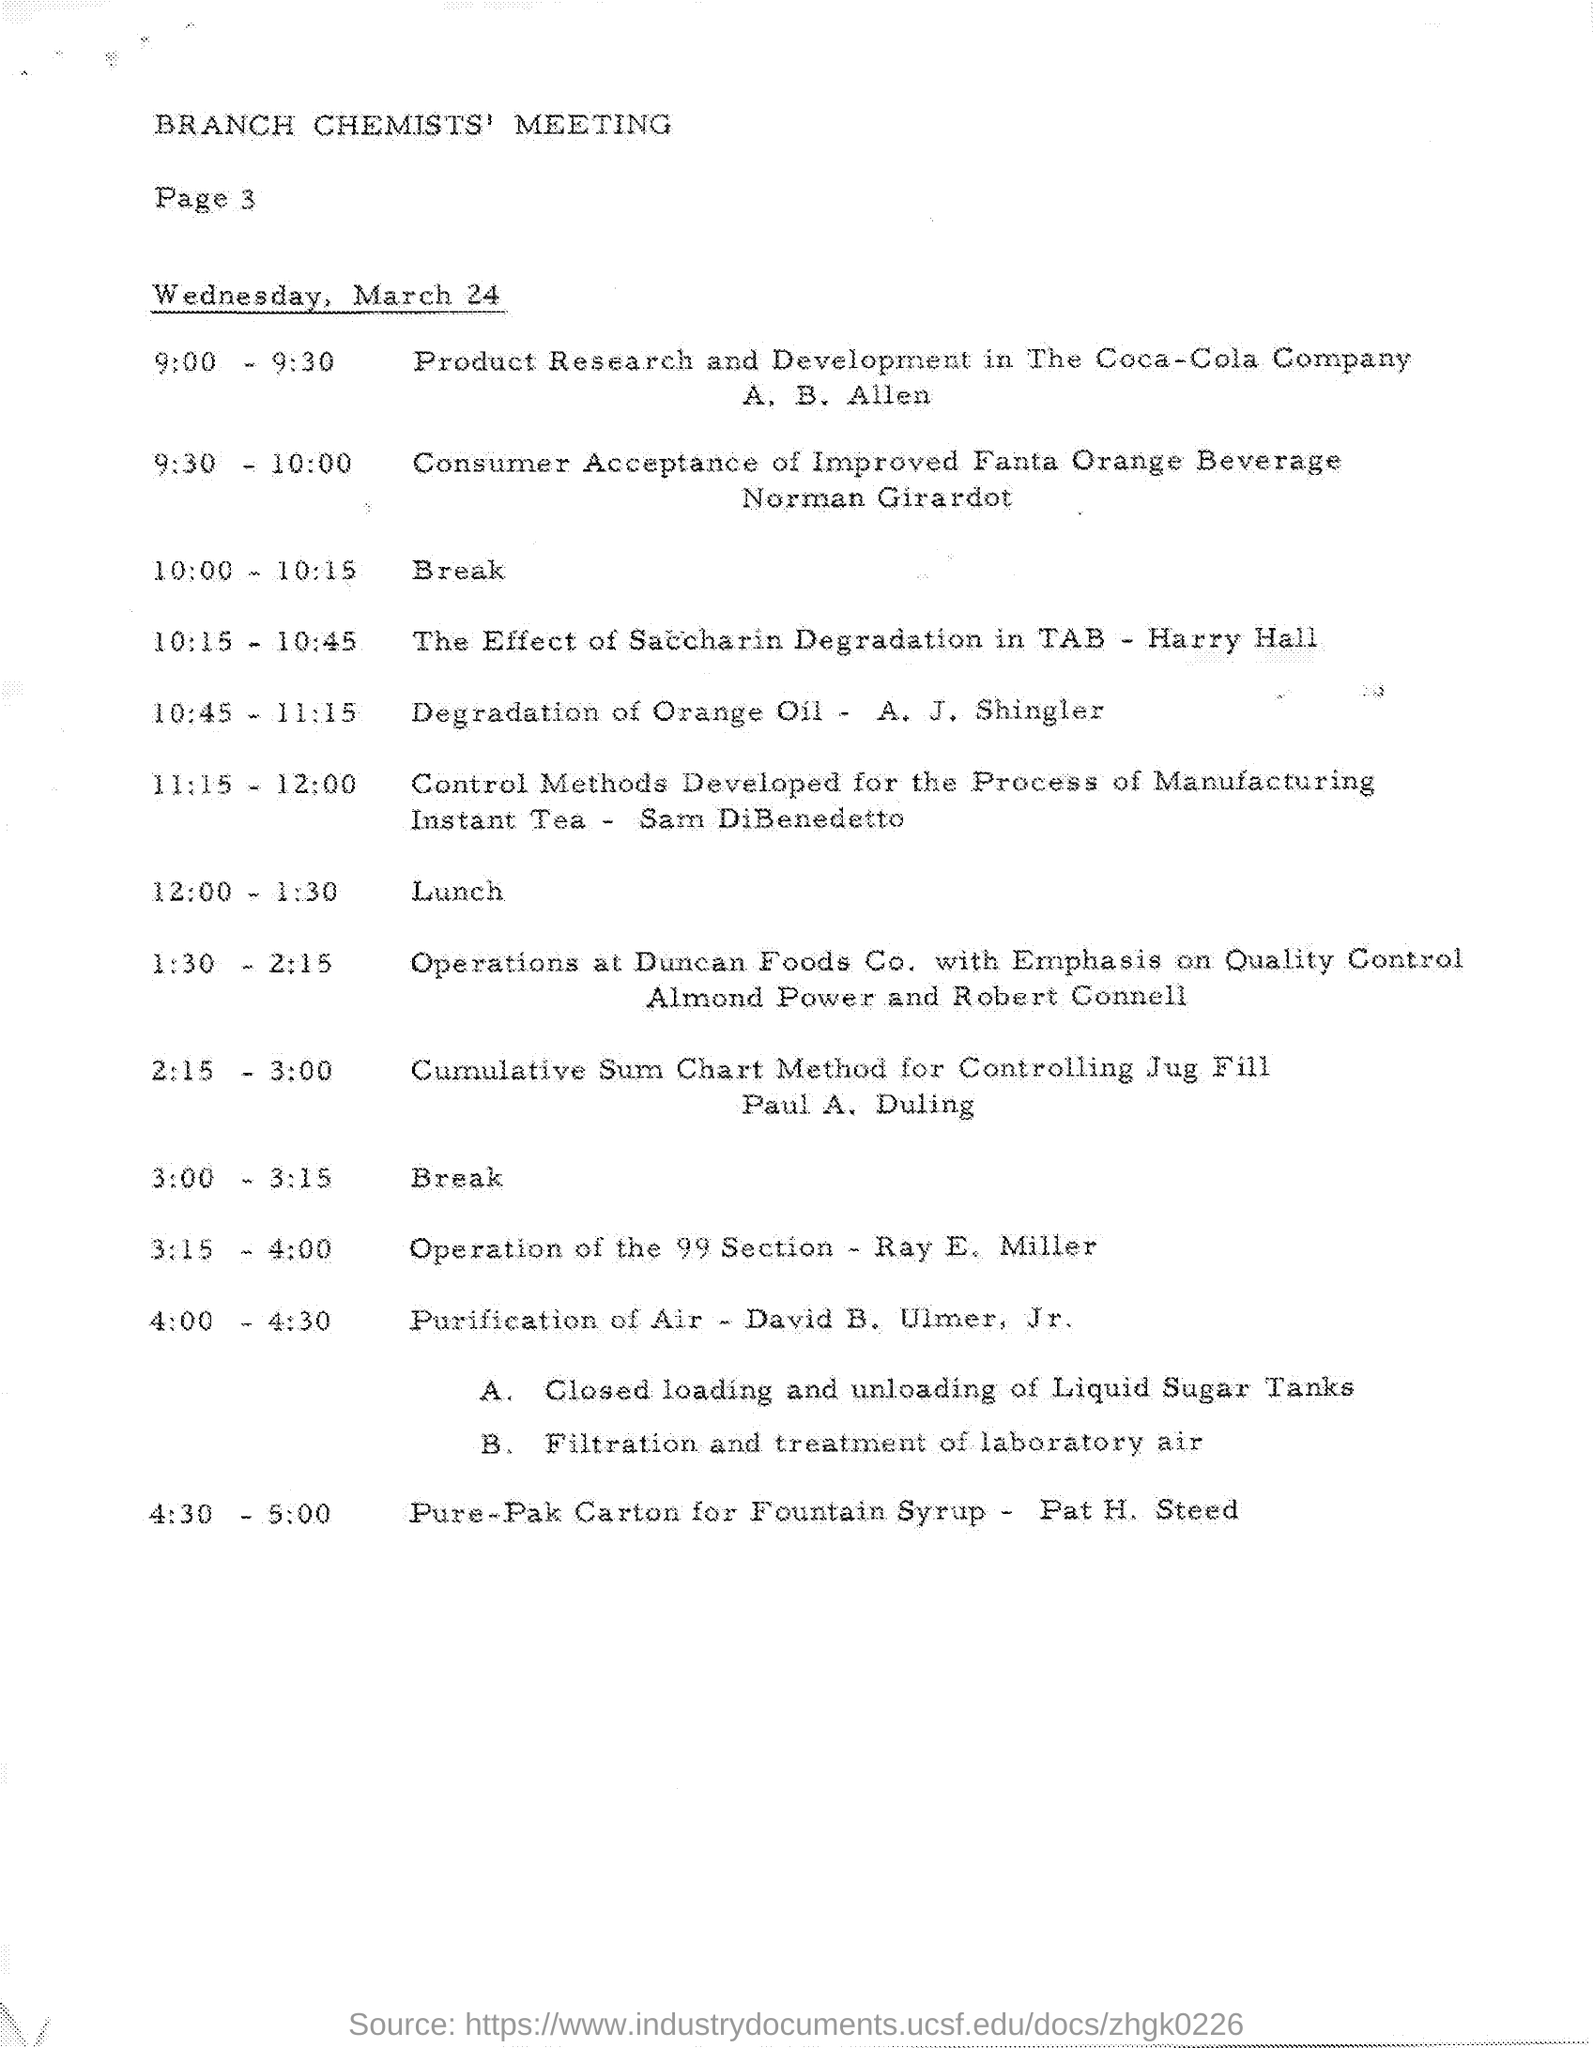What is the document title?
Keep it short and to the point. Branch Chemists' meeting. What is the page number on this document?
Offer a very short reply. Page 3. What is the event from 10:45 - 11:15?
Give a very brief answer. Degradation of Orange Oil. Who is heading Operation of the 99 Section?
Ensure brevity in your answer.  Ray E. Miller. At what time is the topic Purification of Air?
Ensure brevity in your answer.  4:00 - 4:30. 